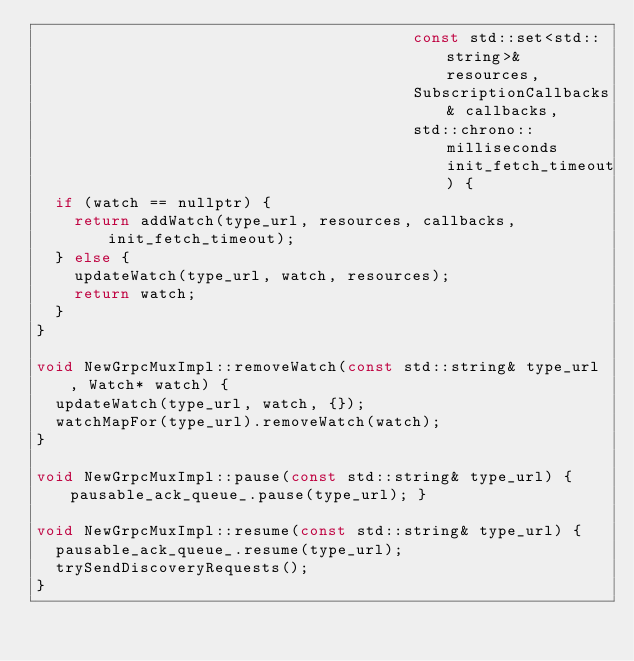Convert code to text. <code><loc_0><loc_0><loc_500><loc_500><_C++_>                                        const std::set<std::string>& resources,
                                        SubscriptionCallbacks& callbacks,
                                        std::chrono::milliseconds init_fetch_timeout) {
  if (watch == nullptr) {
    return addWatch(type_url, resources, callbacks, init_fetch_timeout);
  } else {
    updateWatch(type_url, watch, resources);
    return watch;
  }
}

void NewGrpcMuxImpl::removeWatch(const std::string& type_url, Watch* watch) {
  updateWatch(type_url, watch, {});
  watchMapFor(type_url).removeWatch(watch);
}

void NewGrpcMuxImpl::pause(const std::string& type_url) { pausable_ack_queue_.pause(type_url); }

void NewGrpcMuxImpl::resume(const std::string& type_url) {
  pausable_ack_queue_.resume(type_url);
  trySendDiscoveryRequests();
}
</code> 